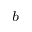<formula> <loc_0><loc_0><loc_500><loc_500>^ { b }</formula> 